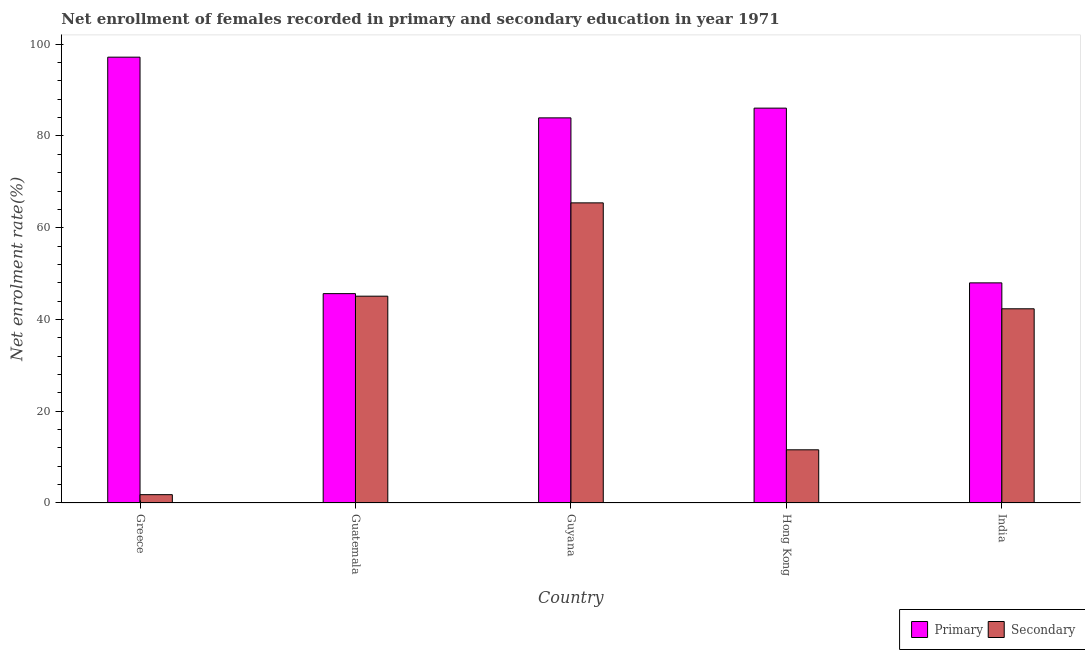How many different coloured bars are there?
Make the answer very short. 2. Are the number of bars per tick equal to the number of legend labels?
Your answer should be compact. Yes. Are the number of bars on each tick of the X-axis equal?
Offer a terse response. Yes. How many bars are there on the 2nd tick from the left?
Ensure brevity in your answer.  2. How many bars are there on the 1st tick from the right?
Your answer should be compact. 2. What is the label of the 3rd group of bars from the left?
Offer a terse response. Guyana. What is the enrollment rate in primary education in Guatemala?
Your answer should be very brief. 45.63. Across all countries, what is the maximum enrollment rate in secondary education?
Give a very brief answer. 65.42. Across all countries, what is the minimum enrollment rate in primary education?
Make the answer very short. 45.63. In which country was the enrollment rate in secondary education maximum?
Your response must be concise. Guyana. In which country was the enrollment rate in primary education minimum?
Your answer should be compact. Guatemala. What is the total enrollment rate in primary education in the graph?
Your answer should be very brief. 360.79. What is the difference between the enrollment rate in primary education in Hong Kong and that in India?
Provide a succinct answer. 38.09. What is the difference between the enrollment rate in secondary education in India and the enrollment rate in primary education in Hong Kong?
Your response must be concise. -43.74. What is the average enrollment rate in primary education per country?
Offer a terse response. 72.16. What is the difference between the enrollment rate in primary education and enrollment rate in secondary education in Guyana?
Provide a short and direct response. 18.53. What is the ratio of the enrollment rate in secondary education in Greece to that in Guatemala?
Provide a short and direct response. 0.04. Is the enrollment rate in primary education in Hong Kong less than that in India?
Keep it short and to the point. No. Is the difference between the enrollment rate in secondary education in Guyana and India greater than the difference between the enrollment rate in primary education in Guyana and India?
Your response must be concise. No. What is the difference between the highest and the second highest enrollment rate in primary education?
Ensure brevity in your answer.  11.11. What is the difference between the highest and the lowest enrollment rate in primary education?
Your answer should be very brief. 51.54. In how many countries, is the enrollment rate in primary education greater than the average enrollment rate in primary education taken over all countries?
Your response must be concise. 3. What does the 1st bar from the left in India represents?
Your response must be concise. Primary. What does the 2nd bar from the right in Greece represents?
Offer a very short reply. Primary. How many bars are there?
Offer a very short reply. 10. Are all the bars in the graph horizontal?
Keep it short and to the point. No. How many countries are there in the graph?
Your answer should be very brief. 5. Are the values on the major ticks of Y-axis written in scientific E-notation?
Provide a short and direct response. No. Does the graph contain any zero values?
Offer a very short reply. No. What is the title of the graph?
Keep it short and to the point. Net enrollment of females recorded in primary and secondary education in year 1971. What is the label or title of the Y-axis?
Keep it short and to the point. Net enrolment rate(%). What is the Net enrolment rate(%) of Primary in Greece?
Provide a short and direct response. 97.17. What is the Net enrolment rate(%) in Secondary in Greece?
Provide a short and direct response. 1.82. What is the Net enrolment rate(%) in Primary in Guatemala?
Provide a short and direct response. 45.63. What is the Net enrolment rate(%) of Secondary in Guatemala?
Offer a terse response. 45.08. What is the Net enrolment rate(%) of Primary in Guyana?
Provide a succinct answer. 83.94. What is the Net enrolment rate(%) of Secondary in Guyana?
Your answer should be compact. 65.42. What is the Net enrolment rate(%) of Primary in Hong Kong?
Keep it short and to the point. 86.07. What is the Net enrolment rate(%) of Secondary in Hong Kong?
Provide a succinct answer. 11.59. What is the Net enrolment rate(%) in Primary in India?
Provide a short and direct response. 47.98. What is the Net enrolment rate(%) of Secondary in India?
Keep it short and to the point. 42.33. Across all countries, what is the maximum Net enrolment rate(%) of Primary?
Make the answer very short. 97.17. Across all countries, what is the maximum Net enrolment rate(%) in Secondary?
Make the answer very short. 65.42. Across all countries, what is the minimum Net enrolment rate(%) of Primary?
Your answer should be very brief. 45.63. Across all countries, what is the minimum Net enrolment rate(%) in Secondary?
Offer a very short reply. 1.82. What is the total Net enrolment rate(%) in Primary in the graph?
Ensure brevity in your answer.  360.79. What is the total Net enrolment rate(%) of Secondary in the graph?
Give a very brief answer. 166.23. What is the difference between the Net enrolment rate(%) of Primary in Greece and that in Guatemala?
Make the answer very short. 51.54. What is the difference between the Net enrolment rate(%) in Secondary in Greece and that in Guatemala?
Keep it short and to the point. -43.26. What is the difference between the Net enrolment rate(%) of Primary in Greece and that in Guyana?
Provide a succinct answer. 13.23. What is the difference between the Net enrolment rate(%) of Secondary in Greece and that in Guyana?
Offer a terse response. -63.6. What is the difference between the Net enrolment rate(%) of Primary in Greece and that in Hong Kong?
Provide a succinct answer. 11.11. What is the difference between the Net enrolment rate(%) of Secondary in Greece and that in Hong Kong?
Your answer should be compact. -9.78. What is the difference between the Net enrolment rate(%) in Primary in Greece and that in India?
Your answer should be compact. 49.2. What is the difference between the Net enrolment rate(%) of Secondary in Greece and that in India?
Your answer should be compact. -40.51. What is the difference between the Net enrolment rate(%) in Primary in Guatemala and that in Guyana?
Give a very brief answer. -38.31. What is the difference between the Net enrolment rate(%) of Secondary in Guatemala and that in Guyana?
Offer a very short reply. -20.34. What is the difference between the Net enrolment rate(%) in Primary in Guatemala and that in Hong Kong?
Offer a very short reply. -40.43. What is the difference between the Net enrolment rate(%) of Secondary in Guatemala and that in Hong Kong?
Your answer should be compact. 33.49. What is the difference between the Net enrolment rate(%) in Primary in Guatemala and that in India?
Your answer should be compact. -2.35. What is the difference between the Net enrolment rate(%) of Secondary in Guatemala and that in India?
Your answer should be very brief. 2.75. What is the difference between the Net enrolment rate(%) of Primary in Guyana and that in Hong Kong?
Provide a succinct answer. -2.12. What is the difference between the Net enrolment rate(%) of Secondary in Guyana and that in Hong Kong?
Make the answer very short. 53.83. What is the difference between the Net enrolment rate(%) in Primary in Guyana and that in India?
Make the answer very short. 35.97. What is the difference between the Net enrolment rate(%) of Secondary in Guyana and that in India?
Ensure brevity in your answer.  23.09. What is the difference between the Net enrolment rate(%) in Primary in Hong Kong and that in India?
Offer a terse response. 38.09. What is the difference between the Net enrolment rate(%) of Secondary in Hong Kong and that in India?
Your answer should be compact. -30.74. What is the difference between the Net enrolment rate(%) of Primary in Greece and the Net enrolment rate(%) of Secondary in Guatemala?
Keep it short and to the point. 52.1. What is the difference between the Net enrolment rate(%) of Primary in Greece and the Net enrolment rate(%) of Secondary in Guyana?
Make the answer very short. 31.76. What is the difference between the Net enrolment rate(%) of Primary in Greece and the Net enrolment rate(%) of Secondary in Hong Kong?
Your response must be concise. 85.58. What is the difference between the Net enrolment rate(%) of Primary in Greece and the Net enrolment rate(%) of Secondary in India?
Ensure brevity in your answer.  54.85. What is the difference between the Net enrolment rate(%) in Primary in Guatemala and the Net enrolment rate(%) in Secondary in Guyana?
Provide a short and direct response. -19.79. What is the difference between the Net enrolment rate(%) of Primary in Guatemala and the Net enrolment rate(%) of Secondary in Hong Kong?
Give a very brief answer. 34.04. What is the difference between the Net enrolment rate(%) of Primary in Guatemala and the Net enrolment rate(%) of Secondary in India?
Your answer should be very brief. 3.3. What is the difference between the Net enrolment rate(%) in Primary in Guyana and the Net enrolment rate(%) in Secondary in Hong Kong?
Provide a short and direct response. 72.35. What is the difference between the Net enrolment rate(%) in Primary in Guyana and the Net enrolment rate(%) in Secondary in India?
Your response must be concise. 41.62. What is the difference between the Net enrolment rate(%) in Primary in Hong Kong and the Net enrolment rate(%) in Secondary in India?
Provide a short and direct response. 43.74. What is the average Net enrolment rate(%) in Primary per country?
Your answer should be very brief. 72.16. What is the average Net enrolment rate(%) in Secondary per country?
Offer a terse response. 33.25. What is the difference between the Net enrolment rate(%) in Primary and Net enrolment rate(%) in Secondary in Greece?
Your answer should be compact. 95.36. What is the difference between the Net enrolment rate(%) of Primary and Net enrolment rate(%) of Secondary in Guatemala?
Offer a very short reply. 0.55. What is the difference between the Net enrolment rate(%) of Primary and Net enrolment rate(%) of Secondary in Guyana?
Your answer should be very brief. 18.53. What is the difference between the Net enrolment rate(%) of Primary and Net enrolment rate(%) of Secondary in Hong Kong?
Provide a short and direct response. 74.47. What is the difference between the Net enrolment rate(%) in Primary and Net enrolment rate(%) in Secondary in India?
Your answer should be compact. 5.65. What is the ratio of the Net enrolment rate(%) of Primary in Greece to that in Guatemala?
Offer a very short reply. 2.13. What is the ratio of the Net enrolment rate(%) of Secondary in Greece to that in Guatemala?
Provide a succinct answer. 0.04. What is the ratio of the Net enrolment rate(%) of Primary in Greece to that in Guyana?
Offer a very short reply. 1.16. What is the ratio of the Net enrolment rate(%) in Secondary in Greece to that in Guyana?
Make the answer very short. 0.03. What is the ratio of the Net enrolment rate(%) of Primary in Greece to that in Hong Kong?
Give a very brief answer. 1.13. What is the ratio of the Net enrolment rate(%) of Secondary in Greece to that in Hong Kong?
Your answer should be very brief. 0.16. What is the ratio of the Net enrolment rate(%) in Primary in Greece to that in India?
Your answer should be compact. 2.03. What is the ratio of the Net enrolment rate(%) of Secondary in Greece to that in India?
Your answer should be compact. 0.04. What is the ratio of the Net enrolment rate(%) in Primary in Guatemala to that in Guyana?
Make the answer very short. 0.54. What is the ratio of the Net enrolment rate(%) in Secondary in Guatemala to that in Guyana?
Ensure brevity in your answer.  0.69. What is the ratio of the Net enrolment rate(%) of Primary in Guatemala to that in Hong Kong?
Ensure brevity in your answer.  0.53. What is the ratio of the Net enrolment rate(%) of Secondary in Guatemala to that in Hong Kong?
Provide a short and direct response. 3.89. What is the ratio of the Net enrolment rate(%) in Primary in Guatemala to that in India?
Make the answer very short. 0.95. What is the ratio of the Net enrolment rate(%) of Secondary in Guatemala to that in India?
Offer a very short reply. 1.06. What is the ratio of the Net enrolment rate(%) in Primary in Guyana to that in Hong Kong?
Your answer should be compact. 0.98. What is the ratio of the Net enrolment rate(%) in Secondary in Guyana to that in Hong Kong?
Offer a very short reply. 5.64. What is the ratio of the Net enrolment rate(%) in Primary in Guyana to that in India?
Make the answer very short. 1.75. What is the ratio of the Net enrolment rate(%) of Secondary in Guyana to that in India?
Your answer should be very brief. 1.55. What is the ratio of the Net enrolment rate(%) in Primary in Hong Kong to that in India?
Provide a short and direct response. 1.79. What is the ratio of the Net enrolment rate(%) in Secondary in Hong Kong to that in India?
Provide a short and direct response. 0.27. What is the difference between the highest and the second highest Net enrolment rate(%) of Primary?
Keep it short and to the point. 11.11. What is the difference between the highest and the second highest Net enrolment rate(%) of Secondary?
Make the answer very short. 20.34. What is the difference between the highest and the lowest Net enrolment rate(%) in Primary?
Provide a short and direct response. 51.54. What is the difference between the highest and the lowest Net enrolment rate(%) of Secondary?
Give a very brief answer. 63.6. 